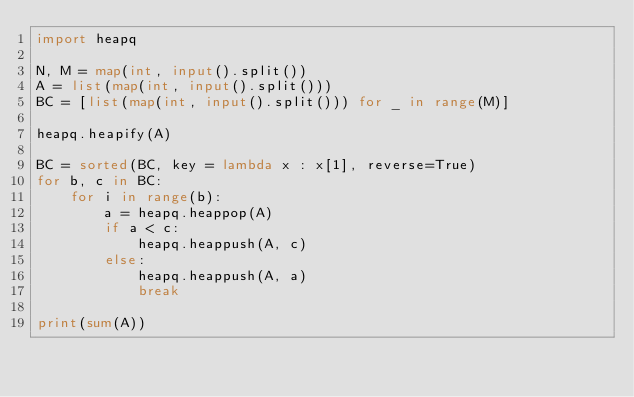Convert code to text. <code><loc_0><loc_0><loc_500><loc_500><_Python_>import heapq

N, M = map(int, input().split())
A = list(map(int, input().split()))
BC = [list(map(int, input().split())) for _ in range(M)]

heapq.heapify(A)

BC = sorted(BC, key = lambda x : x[1], reverse=True)
for b, c in BC:
    for i in range(b):
        a = heapq.heappop(A)
        if a < c:
            heapq.heappush(A, c)
        else:
            heapq.heappush(A, a)
            break

print(sum(A))</code> 